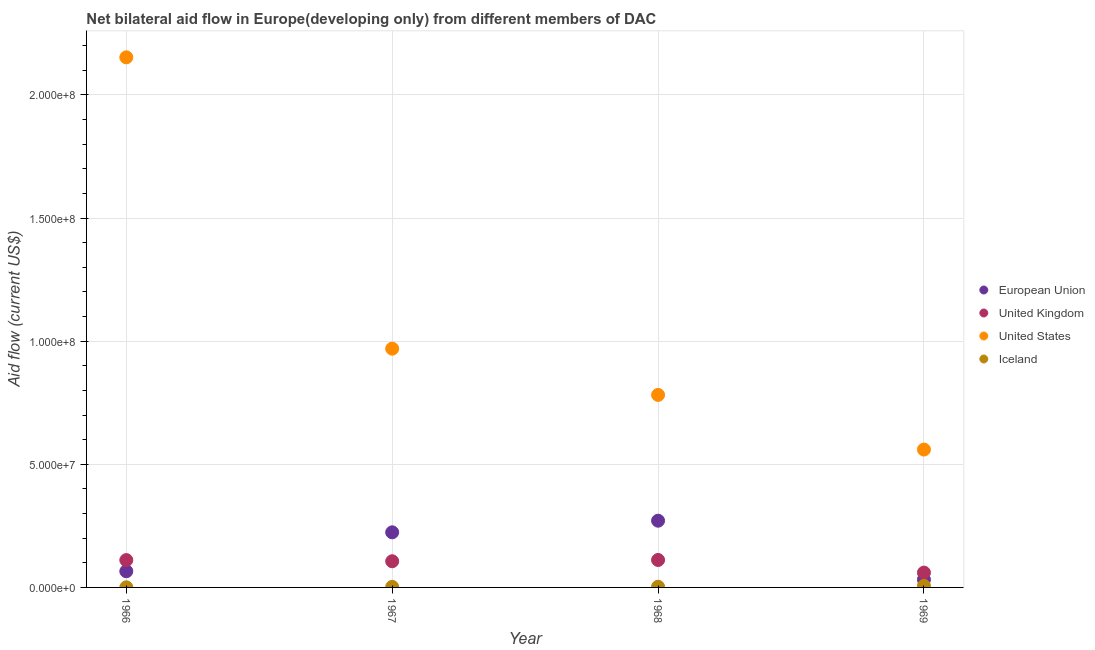What is the amount of aid given by us in 1966?
Make the answer very short. 2.15e+08. Across all years, what is the maximum amount of aid given by uk?
Offer a terse response. 1.12e+07. Across all years, what is the minimum amount of aid given by us?
Your answer should be very brief. 5.60e+07. In which year was the amount of aid given by eu maximum?
Offer a very short reply. 1968. In which year was the amount of aid given by eu minimum?
Ensure brevity in your answer.  1969. What is the total amount of aid given by uk in the graph?
Ensure brevity in your answer.  3.89e+07. What is the difference between the amount of aid given by eu in 1966 and that in 1969?
Make the answer very short. 3.39e+06. What is the difference between the amount of aid given by uk in 1968 and the amount of aid given by us in 1967?
Your answer should be very brief. -8.58e+07. What is the average amount of aid given by iceland per year?
Ensure brevity in your answer.  3.02e+05. In the year 1967, what is the difference between the amount of aid given by uk and amount of aid given by us?
Provide a short and direct response. -8.63e+07. In how many years, is the amount of aid given by eu greater than 60000000 US$?
Make the answer very short. 0. What is the ratio of the amount of aid given by us in 1966 to that in 1969?
Offer a terse response. 3.84. Is the amount of aid given by uk in 1967 less than that in 1969?
Your answer should be compact. No. Is the difference between the amount of aid given by uk in 1966 and 1969 greater than the difference between the amount of aid given by us in 1966 and 1969?
Ensure brevity in your answer.  No. What is the difference between the highest and the lowest amount of aid given by iceland?
Your response must be concise. 6.10e+05. In how many years, is the amount of aid given by us greater than the average amount of aid given by us taken over all years?
Offer a terse response. 1. Is the sum of the amount of aid given by eu in 1966 and 1968 greater than the maximum amount of aid given by uk across all years?
Your answer should be very brief. Yes. Is it the case that in every year, the sum of the amount of aid given by eu and amount of aid given by us is greater than the sum of amount of aid given by iceland and amount of aid given by uk?
Provide a succinct answer. No. Is it the case that in every year, the sum of the amount of aid given by eu and amount of aid given by uk is greater than the amount of aid given by us?
Give a very brief answer. No. Does the amount of aid given by iceland monotonically increase over the years?
Make the answer very short. Yes. Is the amount of aid given by eu strictly greater than the amount of aid given by uk over the years?
Provide a succinct answer. No. Is the amount of aid given by eu strictly less than the amount of aid given by iceland over the years?
Provide a succinct answer. No. How many dotlines are there?
Give a very brief answer. 4. What is the difference between two consecutive major ticks on the Y-axis?
Offer a terse response. 5.00e+07. Does the graph contain any zero values?
Your response must be concise. No. Where does the legend appear in the graph?
Keep it short and to the point. Center right. What is the title of the graph?
Provide a short and direct response. Net bilateral aid flow in Europe(developing only) from different members of DAC. What is the label or title of the X-axis?
Your answer should be compact. Year. What is the Aid flow (current US$) in European Union in 1966?
Provide a short and direct response. 6.57e+06. What is the Aid flow (current US$) in United Kingdom in 1966?
Keep it short and to the point. 1.11e+07. What is the Aid flow (current US$) of United States in 1966?
Give a very brief answer. 2.15e+08. What is the Aid flow (current US$) in European Union in 1967?
Keep it short and to the point. 2.24e+07. What is the Aid flow (current US$) in United Kingdom in 1967?
Ensure brevity in your answer.  1.06e+07. What is the Aid flow (current US$) in United States in 1967?
Make the answer very short. 9.70e+07. What is the Aid flow (current US$) in Iceland in 1967?
Offer a very short reply. 2.20e+05. What is the Aid flow (current US$) of European Union in 1968?
Your response must be concise. 2.71e+07. What is the Aid flow (current US$) of United Kingdom in 1968?
Your response must be concise. 1.12e+07. What is the Aid flow (current US$) in United States in 1968?
Your answer should be compact. 7.82e+07. What is the Aid flow (current US$) of European Union in 1969?
Keep it short and to the point. 3.18e+06. What is the Aid flow (current US$) in United Kingdom in 1969?
Your answer should be compact. 6.01e+06. What is the Aid flow (current US$) in United States in 1969?
Your answer should be compact. 5.60e+07. Across all years, what is the maximum Aid flow (current US$) of European Union?
Your response must be concise. 2.71e+07. Across all years, what is the maximum Aid flow (current US$) of United Kingdom?
Provide a short and direct response. 1.12e+07. Across all years, what is the maximum Aid flow (current US$) in United States?
Provide a succinct answer. 2.15e+08. Across all years, what is the maximum Aid flow (current US$) in Iceland?
Your response must be concise. 6.60e+05. Across all years, what is the minimum Aid flow (current US$) in European Union?
Give a very brief answer. 3.18e+06. Across all years, what is the minimum Aid flow (current US$) in United Kingdom?
Give a very brief answer. 6.01e+06. Across all years, what is the minimum Aid flow (current US$) in United States?
Keep it short and to the point. 5.60e+07. Across all years, what is the minimum Aid flow (current US$) of Iceland?
Ensure brevity in your answer.  5.00e+04. What is the total Aid flow (current US$) of European Union in the graph?
Keep it short and to the point. 5.92e+07. What is the total Aid flow (current US$) of United Kingdom in the graph?
Provide a short and direct response. 3.89e+07. What is the total Aid flow (current US$) of United States in the graph?
Provide a succinct answer. 4.46e+08. What is the total Aid flow (current US$) of Iceland in the graph?
Provide a succinct answer. 1.21e+06. What is the difference between the Aid flow (current US$) in European Union in 1966 and that in 1967?
Make the answer very short. -1.58e+07. What is the difference between the Aid flow (current US$) of United States in 1966 and that in 1967?
Provide a succinct answer. 1.18e+08. What is the difference between the Aid flow (current US$) in European Union in 1966 and that in 1968?
Your response must be concise. -2.05e+07. What is the difference between the Aid flow (current US$) of United Kingdom in 1966 and that in 1968?
Your response must be concise. -5.00e+04. What is the difference between the Aid flow (current US$) of United States in 1966 and that in 1968?
Ensure brevity in your answer.  1.37e+08. What is the difference between the Aid flow (current US$) of Iceland in 1966 and that in 1968?
Make the answer very short. -2.30e+05. What is the difference between the Aid flow (current US$) in European Union in 1966 and that in 1969?
Your answer should be compact. 3.39e+06. What is the difference between the Aid flow (current US$) in United Kingdom in 1966 and that in 1969?
Make the answer very short. 5.09e+06. What is the difference between the Aid flow (current US$) of United States in 1966 and that in 1969?
Provide a short and direct response. 1.59e+08. What is the difference between the Aid flow (current US$) of Iceland in 1966 and that in 1969?
Offer a terse response. -6.10e+05. What is the difference between the Aid flow (current US$) of European Union in 1967 and that in 1968?
Make the answer very short. -4.72e+06. What is the difference between the Aid flow (current US$) in United Kingdom in 1967 and that in 1968?
Your answer should be compact. -5.20e+05. What is the difference between the Aid flow (current US$) of United States in 1967 and that in 1968?
Keep it short and to the point. 1.88e+07. What is the difference between the Aid flow (current US$) of Iceland in 1967 and that in 1968?
Your response must be concise. -6.00e+04. What is the difference between the Aid flow (current US$) of European Union in 1967 and that in 1969?
Your response must be concise. 1.92e+07. What is the difference between the Aid flow (current US$) of United Kingdom in 1967 and that in 1969?
Offer a very short reply. 4.62e+06. What is the difference between the Aid flow (current US$) in United States in 1967 and that in 1969?
Your answer should be very brief. 4.10e+07. What is the difference between the Aid flow (current US$) in Iceland in 1967 and that in 1969?
Ensure brevity in your answer.  -4.40e+05. What is the difference between the Aid flow (current US$) of European Union in 1968 and that in 1969?
Provide a short and direct response. 2.39e+07. What is the difference between the Aid flow (current US$) of United Kingdom in 1968 and that in 1969?
Your answer should be compact. 5.14e+06. What is the difference between the Aid flow (current US$) in United States in 1968 and that in 1969?
Provide a short and direct response. 2.22e+07. What is the difference between the Aid flow (current US$) of Iceland in 1968 and that in 1969?
Offer a terse response. -3.80e+05. What is the difference between the Aid flow (current US$) of European Union in 1966 and the Aid flow (current US$) of United Kingdom in 1967?
Offer a very short reply. -4.06e+06. What is the difference between the Aid flow (current US$) in European Union in 1966 and the Aid flow (current US$) in United States in 1967?
Ensure brevity in your answer.  -9.04e+07. What is the difference between the Aid flow (current US$) in European Union in 1966 and the Aid flow (current US$) in Iceland in 1967?
Provide a short and direct response. 6.35e+06. What is the difference between the Aid flow (current US$) of United Kingdom in 1966 and the Aid flow (current US$) of United States in 1967?
Provide a succinct answer. -8.59e+07. What is the difference between the Aid flow (current US$) in United Kingdom in 1966 and the Aid flow (current US$) in Iceland in 1967?
Offer a very short reply. 1.09e+07. What is the difference between the Aid flow (current US$) of United States in 1966 and the Aid flow (current US$) of Iceland in 1967?
Ensure brevity in your answer.  2.15e+08. What is the difference between the Aid flow (current US$) of European Union in 1966 and the Aid flow (current US$) of United Kingdom in 1968?
Your answer should be compact. -4.58e+06. What is the difference between the Aid flow (current US$) in European Union in 1966 and the Aid flow (current US$) in United States in 1968?
Your response must be concise. -7.16e+07. What is the difference between the Aid flow (current US$) of European Union in 1966 and the Aid flow (current US$) of Iceland in 1968?
Provide a succinct answer. 6.29e+06. What is the difference between the Aid flow (current US$) in United Kingdom in 1966 and the Aid flow (current US$) in United States in 1968?
Provide a succinct answer. -6.71e+07. What is the difference between the Aid flow (current US$) in United Kingdom in 1966 and the Aid flow (current US$) in Iceland in 1968?
Offer a terse response. 1.08e+07. What is the difference between the Aid flow (current US$) of United States in 1966 and the Aid flow (current US$) of Iceland in 1968?
Make the answer very short. 2.15e+08. What is the difference between the Aid flow (current US$) of European Union in 1966 and the Aid flow (current US$) of United Kingdom in 1969?
Provide a succinct answer. 5.60e+05. What is the difference between the Aid flow (current US$) in European Union in 1966 and the Aid flow (current US$) in United States in 1969?
Provide a succinct answer. -4.94e+07. What is the difference between the Aid flow (current US$) of European Union in 1966 and the Aid flow (current US$) of Iceland in 1969?
Give a very brief answer. 5.91e+06. What is the difference between the Aid flow (current US$) in United Kingdom in 1966 and the Aid flow (current US$) in United States in 1969?
Your answer should be very brief. -4.49e+07. What is the difference between the Aid flow (current US$) in United Kingdom in 1966 and the Aid flow (current US$) in Iceland in 1969?
Provide a short and direct response. 1.04e+07. What is the difference between the Aid flow (current US$) of United States in 1966 and the Aid flow (current US$) of Iceland in 1969?
Ensure brevity in your answer.  2.15e+08. What is the difference between the Aid flow (current US$) of European Union in 1967 and the Aid flow (current US$) of United Kingdom in 1968?
Provide a succinct answer. 1.12e+07. What is the difference between the Aid flow (current US$) in European Union in 1967 and the Aid flow (current US$) in United States in 1968?
Keep it short and to the point. -5.58e+07. What is the difference between the Aid flow (current US$) of European Union in 1967 and the Aid flow (current US$) of Iceland in 1968?
Offer a terse response. 2.21e+07. What is the difference between the Aid flow (current US$) of United Kingdom in 1967 and the Aid flow (current US$) of United States in 1968?
Keep it short and to the point. -6.76e+07. What is the difference between the Aid flow (current US$) in United Kingdom in 1967 and the Aid flow (current US$) in Iceland in 1968?
Offer a very short reply. 1.04e+07. What is the difference between the Aid flow (current US$) in United States in 1967 and the Aid flow (current US$) in Iceland in 1968?
Make the answer very short. 9.67e+07. What is the difference between the Aid flow (current US$) of European Union in 1967 and the Aid flow (current US$) of United Kingdom in 1969?
Ensure brevity in your answer.  1.64e+07. What is the difference between the Aid flow (current US$) of European Union in 1967 and the Aid flow (current US$) of United States in 1969?
Ensure brevity in your answer.  -3.36e+07. What is the difference between the Aid flow (current US$) in European Union in 1967 and the Aid flow (current US$) in Iceland in 1969?
Your answer should be very brief. 2.17e+07. What is the difference between the Aid flow (current US$) of United Kingdom in 1967 and the Aid flow (current US$) of United States in 1969?
Your answer should be very brief. -4.54e+07. What is the difference between the Aid flow (current US$) of United Kingdom in 1967 and the Aid flow (current US$) of Iceland in 1969?
Provide a succinct answer. 9.97e+06. What is the difference between the Aid flow (current US$) in United States in 1967 and the Aid flow (current US$) in Iceland in 1969?
Ensure brevity in your answer.  9.63e+07. What is the difference between the Aid flow (current US$) of European Union in 1968 and the Aid flow (current US$) of United Kingdom in 1969?
Your answer should be very brief. 2.11e+07. What is the difference between the Aid flow (current US$) of European Union in 1968 and the Aid flow (current US$) of United States in 1969?
Give a very brief answer. -2.89e+07. What is the difference between the Aid flow (current US$) of European Union in 1968 and the Aid flow (current US$) of Iceland in 1969?
Offer a very short reply. 2.64e+07. What is the difference between the Aid flow (current US$) of United Kingdom in 1968 and the Aid flow (current US$) of United States in 1969?
Ensure brevity in your answer.  -4.48e+07. What is the difference between the Aid flow (current US$) in United Kingdom in 1968 and the Aid flow (current US$) in Iceland in 1969?
Your response must be concise. 1.05e+07. What is the difference between the Aid flow (current US$) in United States in 1968 and the Aid flow (current US$) in Iceland in 1969?
Your response must be concise. 7.75e+07. What is the average Aid flow (current US$) of European Union per year?
Keep it short and to the point. 1.48e+07. What is the average Aid flow (current US$) in United Kingdom per year?
Your answer should be compact. 9.72e+06. What is the average Aid flow (current US$) of United States per year?
Make the answer very short. 1.12e+08. What is the average Aid flow (current US$) of Iceland per year?
Provide a succinct answer. 3.02e+05. In the year 1966, what is the difference between the Aid flow (current US$) of European Union and Aid flow (current US$) of United Kingdom?
Provide a short and direct response. -4.53e+06. In the year 1966, what is the difference between the Aid flow (current US$) in European Union and Aid flow (current US$) in United States?
Give a very brief answer. -2.09e+08. In the year 1966, what is the difference between the Aid flow (current US$) of European Union and Aid flow (current US$) of Iceland?
Keep it short and to the point. 6.52e+06. In the year 1966, what is the difference between the Aid flow (current US$) in United Kingdom and Aid flow (current US$) in United States?
Your answer should be very brief. -2.04e+08. In the year 1966, what is the difference between the Aid flow (current US$) in United Kingdom and Aid flow (current US$) in Iceland?
Provide a succinct answer. 1.10e+07. In the year 1966, what is the difference between the Aid flow (current US$) of United States and Aid flow (current US$) of Iceland?
Ensure brevity in your answer.  2.15e+08. In the year 1967, what is the difference between the Aid flow (current US$) of European Union and Aid flow (current US$) of United Kingdom?
Your response must be concise. 1.18e+07. In the year 1967, what is the difference between the Aid flow (current US$) of European Union and Aid flow (current US$) of United States?
Give a very brief answer. -7.46e+07. In the year 1967, what is the difference between the Aid flow (current US$) of European Union and Aid flow (current US$) of Iceland?
Provide a succinct answer. 2.22e+07. In the year 1967, what is the difference between the Aid flow (current US$) in United Kingdom and Aid flow (current US$) in United States?
Provide a succinct answer. -8.63e+07. In the year 1967, what is the difference between the Aid flow (current US$) of United Kingdom and Aid flow (current US$) of Iceland?
Your response must be concise. 1.04e+07. In the year 1967, what is the difference between the Aid flow (current US$) in United States and Aid flow (current US$) in Iceland?
Give a very brief answer. 9.68e+07. In the year 1968, what is the difference between the Aid flow (current US$) in European Union and Aid flow (current US$) in United Kingdom?
Give a very brief answer. 1.60e+07. In the year 1968, what is the difference between the Aid flow (current US$) of European Union and Aid flow (current US$) of United States?
Make the answer very short. -5.11e+07. In the year 1968, what is the difference between the Aid flow (current US$) of European Union and Aid flow (current US$) of Iceland?
Keep it short and to the point. 2.68e+07. In the year 1968, what is the difference between the Aid flow (current US$) of United Kingdom and Aid flow (current US$) of United States?
Provide a short and direct response. -6.70e+07. In the year 1968, what is the difference between the Aid flow (current US$) of United Kingdom and Aid flow (current US$) of Iceland?
Your answer should be very brief. 1.09e+07. In the year 1968, what is the difference between the Aid flow (current US$) in United States and Aid flow (current US$) in Iceland?
Provide a succinct answer. 7.79e+07. In the year 1969, what is the difference between the Aid flow (current US$) of European Union and Aid flow (current US$) of United Kingdom?
Offer a terse response. -2.83e+06. In the year 1969, what is the difference between the Aid flow (current US$) in European Union and Aid flow (current US$) in United States?
Offer a terse response. -5.28e+07. In the year 1969, what is the difference between the Aid flow (current US$) in European Union and Aid flow (current US$) in Iceland?
Your answer should be very brief. 2.52e+06. In the year 1969, what is the difference between the Aid flow (current US$) of United Kingdom and Aid flow (current US$) of United States?
Give a very brief answer. -5.00e+07. In the year 1969, what is the difference between the Aid flow (current US$) of United Kingdom and Aid flow (current US$) of Iceland?
Your response must be concise. 5.35e+06. In the year 1969, what is the difference between the Aid flow (current US$) of United States and Aid flow (current US$) of Iceland?
Offer a terse response. 5.53e+07. What is the ratio of the Aid flow (current US$) of European Union in 1966 to that in 1967?
Your answer should be compact. 0.29. What is the ratio of the Aid flow (current US$) of United Kingdom in 1966 to that in 1967?
Your answer should be very brief. 1.04. What is the ratio of the Aid flow (current US$) in United States in 1966 to that in 1967?
Ensure brevity in your answer.  2.22. What is the ratio of the Aid flow (current US$) in Iceland in 1966 to that in 1967?
Give a very brief answer. 0.23. What is the ratio of the Aid flow (current US$) in European Union in 1966 to that in 1968?
Give a very brief answer. 0.24. What is the ratio of the Aid flow (current US$) in United States in 1966 to that in 1968?
Give a very brief answer. 2.75. What is the ratio of the Aid flow (current US$) of Iceland in 1966 to that in 1968?
Your answer should be compact. 0.18. What is the ratio of the Aid flow (current US$) in European Union in 1966 to that in 1969?
Provide a succinct answer. 2.07. What is the ratio of the Aid flow (current US$) in United Kingdom in 1966 to that in 1969?
Provide a succinct answer. 1.85. What is the ratio of the Aid flow (current US$) of United States in 1966 to that in 1969?
Your answer should be very brief. 3.84. What is the ratio of the Aid flow (current US$) of Iceland in 1966 to that in 1969?
Your response must be concise. 0.08. What is the ratio of the Aid flow (current US$) in European Union in 1967 to that in 1968?
Your response must be concise. 0.83. What is the ratio of the Aid flow (current US$) in United Kingdom in 1967 to that in 1968?
Your answer should be very brief. 0.95. What is the ratio of the Aid flow (current US$) of United States in 1967 to that in 1968?
Provide a succinct answer. 1.24. What is the ratio of the Aid flow (current US$) in Iceland in 1967 to that in 1968?
Provide a succinct answer. 0.79. What is the ratio of the Aid flow (current US$) in European Union in 1967 to that in 1969?
Make the answer very short. 7.04. What is the ratio of the Aid flow (current US$) in United Kingdom in 1967 to that in 1969?
Keep it short and to the point. 1.77. What is the ratio of the Aid flow (current US$) in United States in 1967 to that in 1969?
Provide a short and direct response. 1.73. What is the ratio of the Aid flow (current US$) of European Union in 1968 to that in 1969?
Your answer should be very brief. 8.52. What is the ratio of the Aid flow (current US$) in United Kingdom in 1968 to that in 1969?
Offer a terse response. 1.86. What is the ratio of the Aid flow (current US$) of United States in 1968 to that in 1969?
Give a very brief answer. 1.4. What is the ratio of the Aid flow (current US$) in Iceland in 1968 to that in 1969?
Your answer should be very brief. 0.42. What is the difference between the highest and the second highest Aid flow (current US$) in European Union?
Your response must be concise. 4.72e+06. What is the difference between the highest and the second highest Aid flow (current US$) in United States?
Your answer should be compact. 1.18e+08. What is the difference between the highest and the lowest Aid flow (current US$) of European Union?
Keep it short and to the point. 2.39e+07. What is the difference between the highest and the lowest Aid flow (current US$) in United Kingdom?
Offer a very short reply. 5.14e+06. What is the difference between the highest and the lowest Aid flow (current US$) of United States?
Give a very brief answer. 1.59e+08. What is the difference between the highest and the lowest Aid flow (current US$) in Iceland?
Your answer should be very brief. 6.10e+05. 